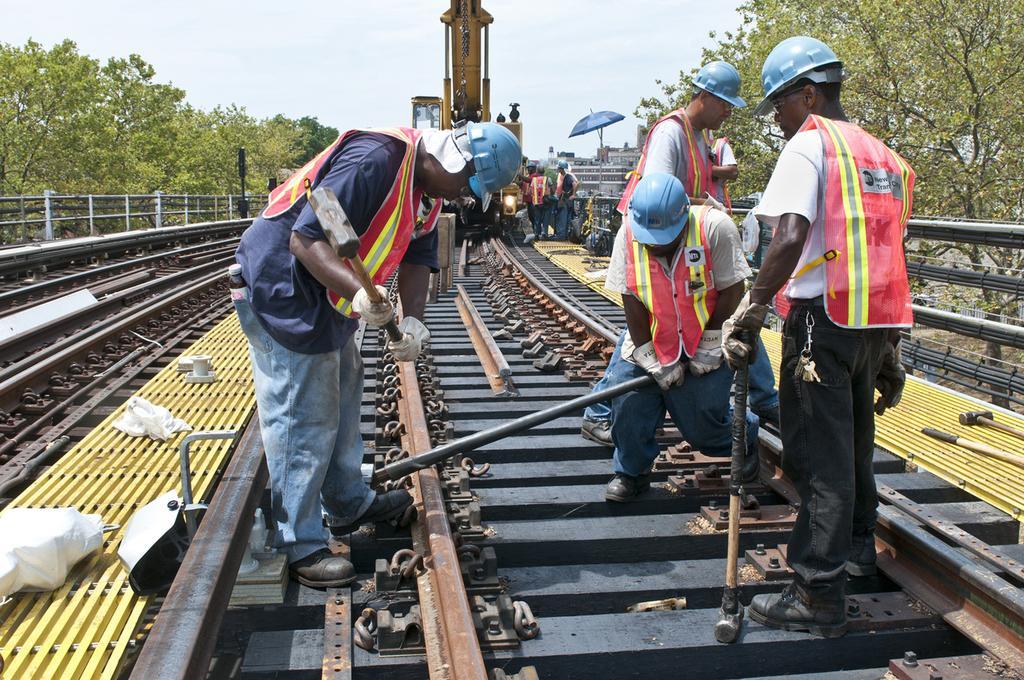In one or two sentences, can you explain what this image depicts? In this picture there are group of people standing and holding the objects. At the back there is a vehicle and there are group of people standing on the railway track and there is an umbrella and there are buildings and trees. At the top there is sky. At the bottom there are railway tracks. 